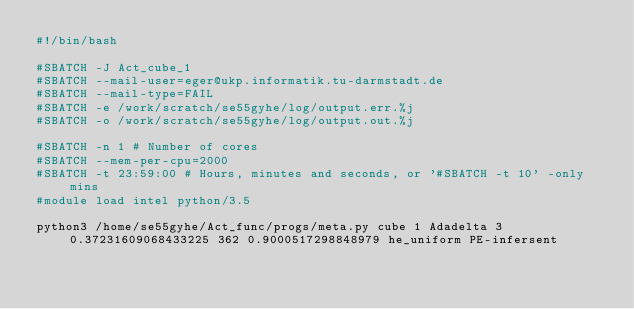Convert code to text. <code><loc_0><loc_0><loc_500><loc_500><_Bash_>#!/bin/bash
 
#SBATCH -J Act_cube_1
#SBATCH --mail-user=eger@ukp.informatik.tu-darmstadt.de
#SBATCH --mail-type=FAIL
#SBATCH -e /work/scratch/se55gyhe/log/output.err.%j
#SBATCH -o /work/scratch/se55gyhe/log/output.out.%j

#SBATCH -n 1 # Number of cores
#SBATCH --mem-per-cpu=2000
#SBATCH -t 23:59:00 # Hours, minutes and seconds, or '#SBATCH -t 10' -only mins
#module load intel python/3.5

python3 /home/se55gyhe/Act_func/progs/meta.py cube 1 Adadelta 3 0.37231609068433225 362 0.9000517298848979 he_uniform PE-infersent 

</code> 